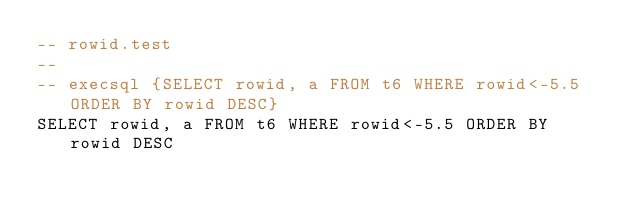Convert code to text. <code><loc_0><loc_0><loc_500><loc_500><_SQL_>-- rowid.test
-- 
-- execsql {SELECT rowid, a FROM t6 WHERE rowid<-5.5 ORDER BY rowid DESC}
SELECT rowid, a FROM t6 WHERE rowid<-5.5 ORDER BY rowid DESC</code> 